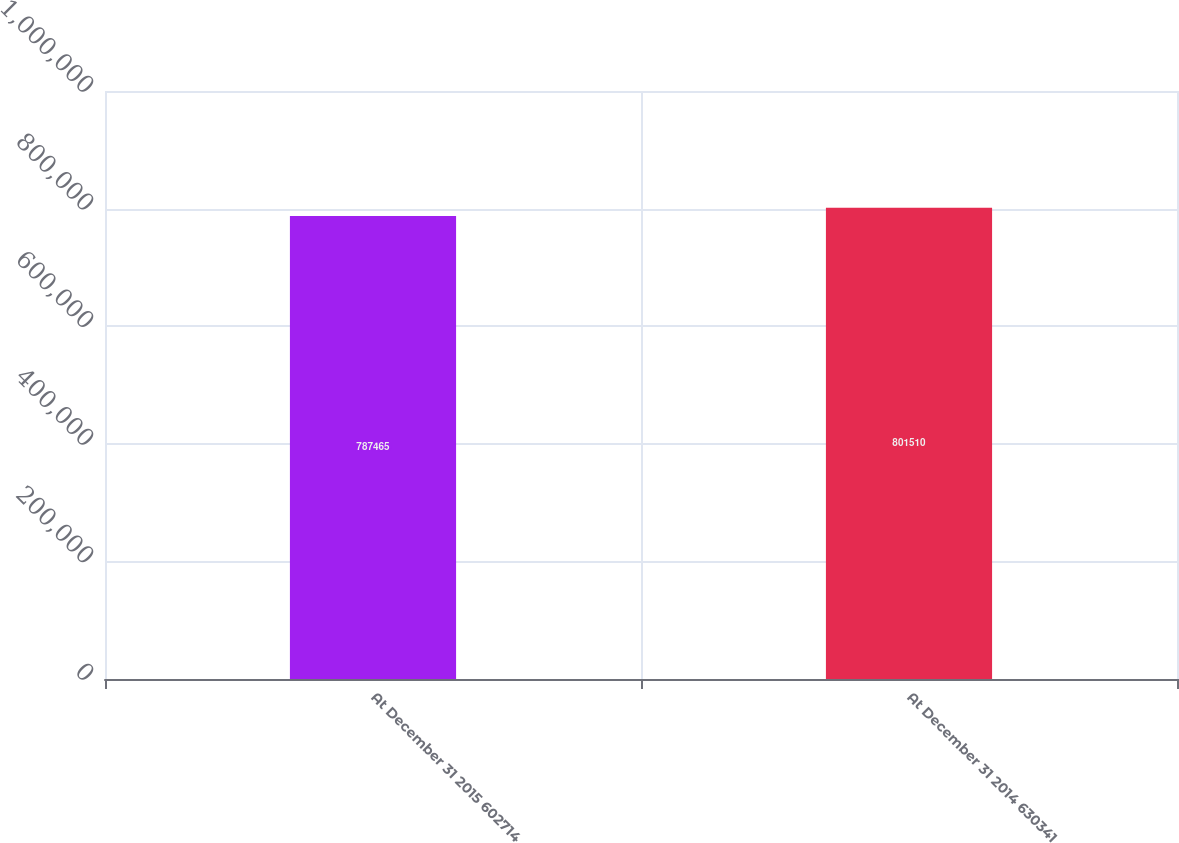Convert chart to OTSL. <chart><loc_0><loc_0><loc_500><loc_500><bar_chart><fcel>At December 31 2015 602714<fcel>At December 31 2014 630341<nl><fcel>787465<fcel>801510<nl></chart> 